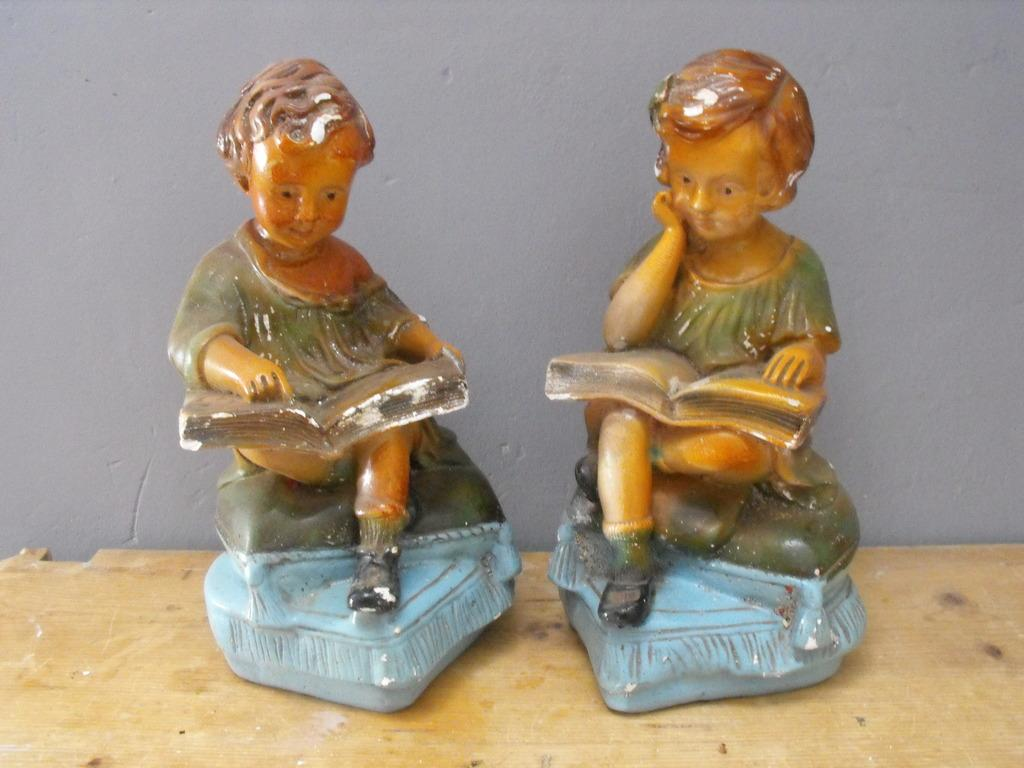How many statues are present in the image? There are two statues in the image. What is the statues placed on in the image? The statues are on a wooden surface. What can be seen in the background of the image? There is a wall in the background of the image. What type of rail can be seen connecting the two statues in the image? There is no rail connecting the two statues in the image. How is the sand distributed around the statues in the image? There is no sand present in the image. 